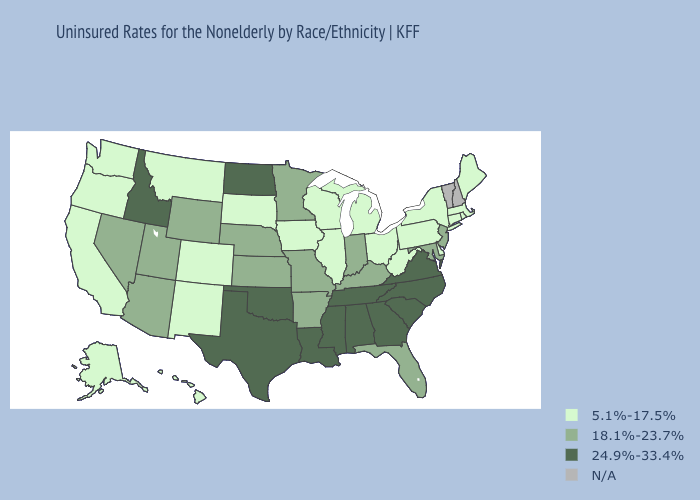Name the states that have a value in the range 24.9%-33.4%?
Short answer required. Alabama, Georgia, Idaho, Louisiana, Mississippi, North Carolina, North Dakota, Oklahoma, South Carolina, Tennessee, Texas, Virginia. Does Alabama have the lowest value in the South?
Keep it brief. No. Among the states that border Indiana , does Kentucky have the highest value?
Concise answer only. Yes. Does Connecticut have the highest value in the Northeast?
Quick response, please. No. What is the value of Massachusetts?
Short answer required. 5.1%-17.5%. Is the legend a continuous bar?
Write a very short answer. No. Name the states that have a value in the range 18.1%-23.7%?
Concise answer only. Arizona, Arkansas, Florida, Indiana, Kansas, Kentucky, Maryland, Minnesota, Missouri, Nebraska, Nevada, New Jersey, Utah, Wyoming. Name the states that have a value in the range 18.1%-23.7%?
Quick response, please. Arizona, Arkansas, Florida, Indiana, Kansas, Kentucky, Maryland, Minnesota, Missouri, Nebraska, Nevada, New Jersey, Utah, Wyoming. What is the highest value in states that border South Carolina?
Answer briefly. 24.9%-33.4%. Name the states that have a value in the range N/A?
Quick response, please. New Hampshire, Vermont. Name the states that have a value in the range N/A?
Keep it brief. New Hampshire, Vermont. Name the states that have a value in the range 5.1%-17.5%?
Write a very short answer. Alaska, California, Colorado, Connecticut, Delaware, Hawaii, Illinois, Iowa, Maine, Massachusetts, Michigan, Montana, New Mexico, New York, Ohio, Oregon, Pennsylvania, Rhode Island, South Dakota, Washington, West Virginia, Wisconsin. Which states have the highest value in the USA?
Be succinct. Alabama, Georgia, Idaho, Louisiana, Mississippi, North Carolina, North Dakota, Oklahoma, South Carolina, Tennessee, Texas, Virginia. 